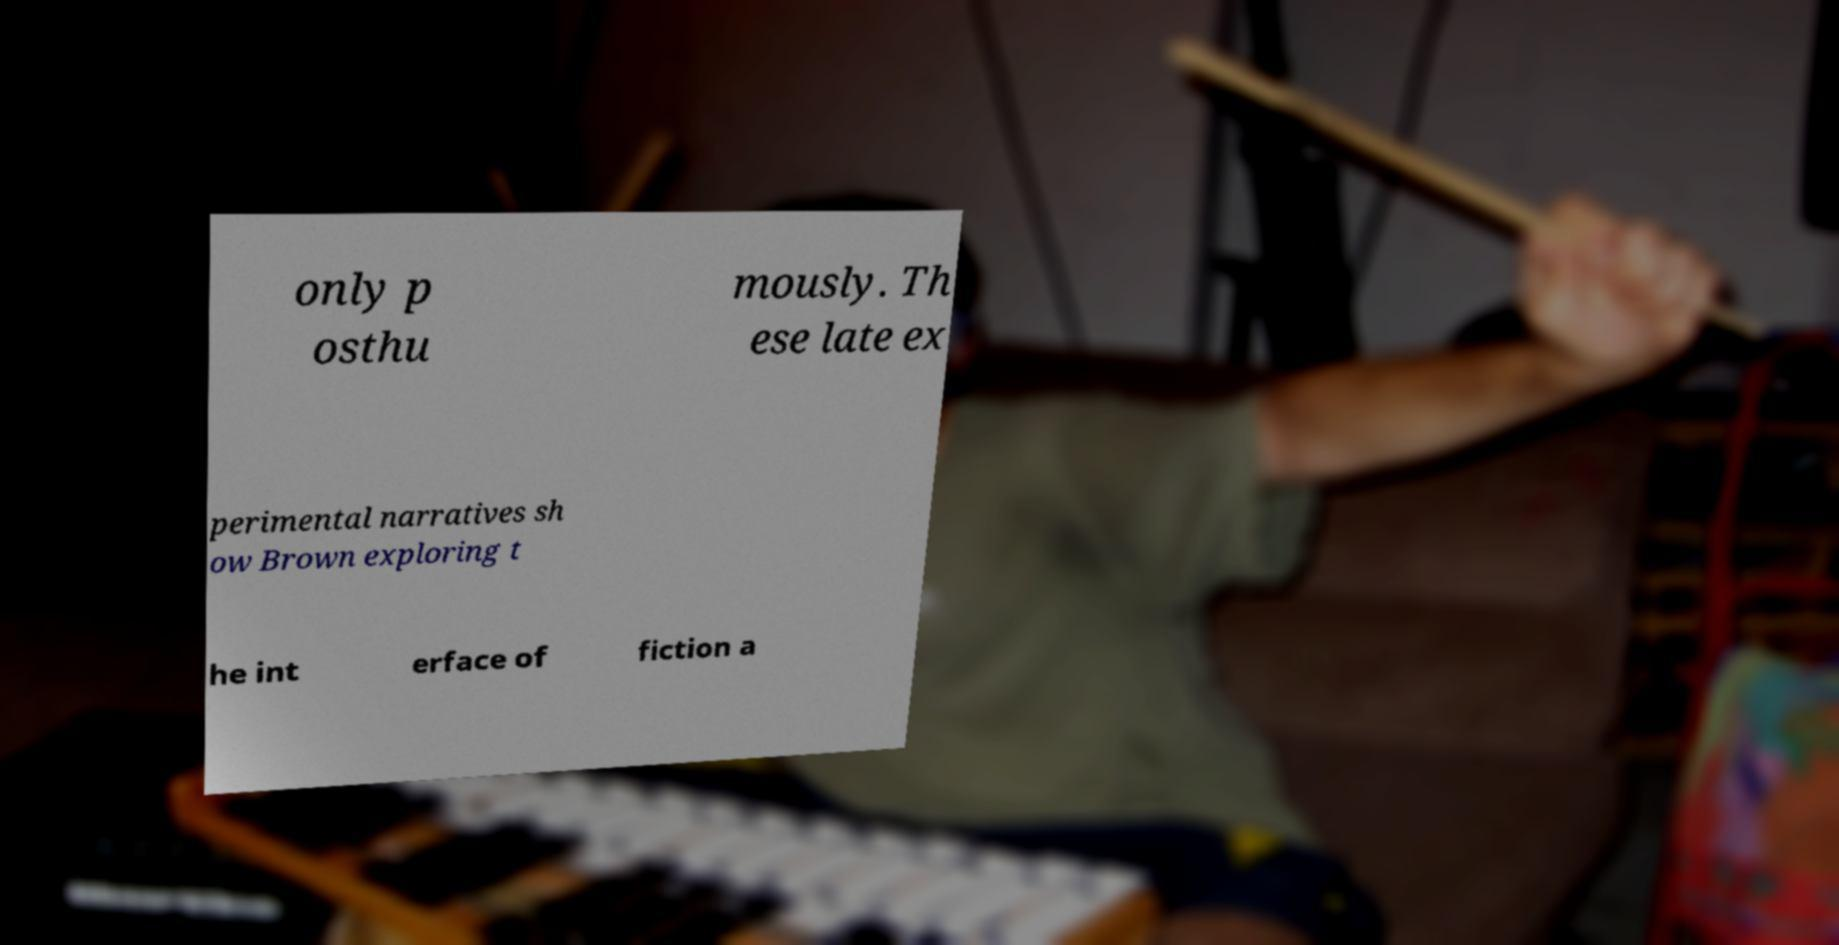There's text embedded in this image that I need extracted. Can you transcribe it verbatim? only p osthu mously. Th ese late ex perimental narratives sh ow Brown exploring t he int erface of fiction a 